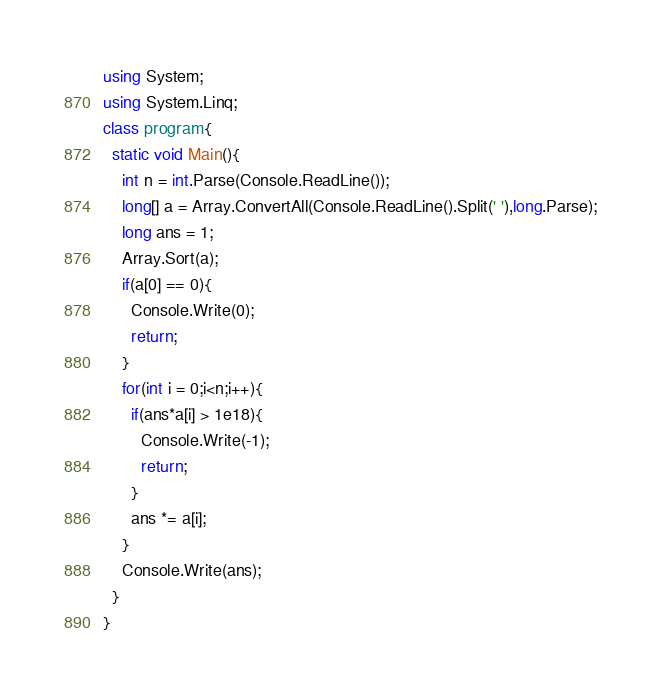Convert code to text. <code><loc_0><loc_0><loc_500><loc_500><_C#_>using System;
using System.Linq;
class program{
  static void Main(){
    int n = int.Parse(Console.ReadLine());
    long[] a = Array.ConvertAll(Console.ReadLine().Split(' '),long.Parse);
    long ans = 1;
    Array.Sort(a);
    if(a[0] == 0){
      Console.Write(0);
      return;
    }
    for(int i = 0;i<n;i++){
      if(ans*a[i] > 1e18){
        Console.Write(-1);
      	return;
      }
      ans *= a[i];
    }
    Console.Write(ans);
  }
}</code> 